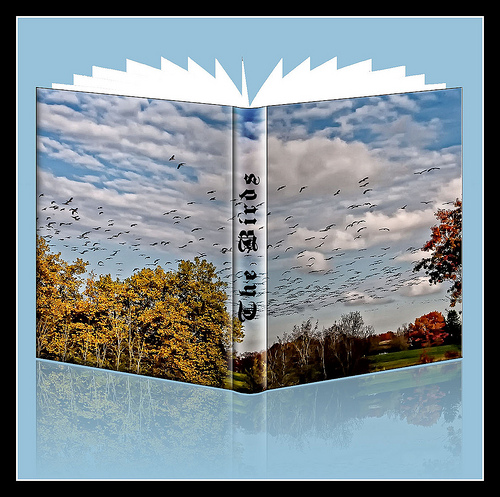<image>
Can you confirm if the trees is on the book? Yes. Looking at the image, I can see the trees is positioned on top of the book, with the book providing support. Is there a cloud on the book? Yes. Looking at the image, I can see the cloud is positioned on top of the book, with the book providing support. 